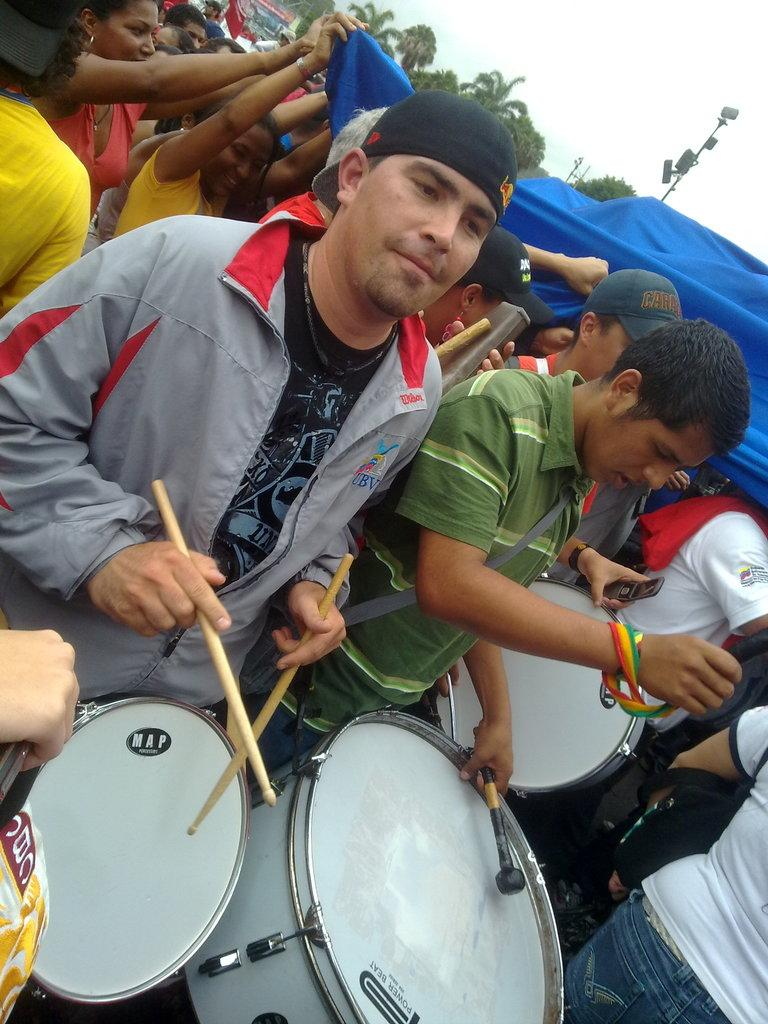What activity are the people in the image engaged in? The people in the image are playing drums. What can be seen in the background of the image? There are trees and tents in the background of the image. How many people are visible in the background? There are many people in the background of the image. How many ladybugs can be seen on the drums in the image? There are no ladybugs visible on the drums in the image. What type of guitar is being played by the person in the image? There is no guitar present in the image; the people are playing drums. 